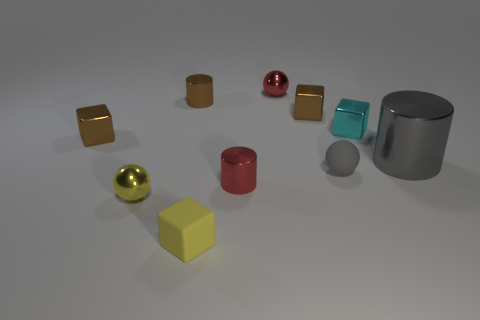Subtract all green cubes. Subtract all green cylinders. How many cubes are left? 4 Subtract all spheres. How many objects are left? 7 Add 4 tiny yellow spheres. How many tiny yellow spheres exist? 5 Subtract 1 red cylinders. How many objects are left? 9 Subtract all small red cylinders. Subtract all gray metal objects. How many objects are left? 8 Add 4 small gray rubber spheres. How many small gray rubber spheres are left? 5 